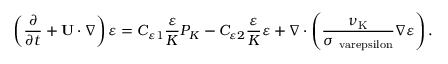<formula> <loc_0><loc_0><loc_500><loc_500>\left ( { \frac { \partial } { \partial t } + { U } \cdot \nabla } \right ) \varepsilon = C _ { \varepsilon 1 } \frac { \varepsilon } { K } P _ { K } - C _ { \varepsilon 2 } \frac { \varepsilon } { K } \varepsilon + \nabla \cdot \left ( { \frac { \nu _ { K } } { \sigma _ { \ v a r e p s i l o n } } \nabla \varepsilon } \right ) .</formula> 